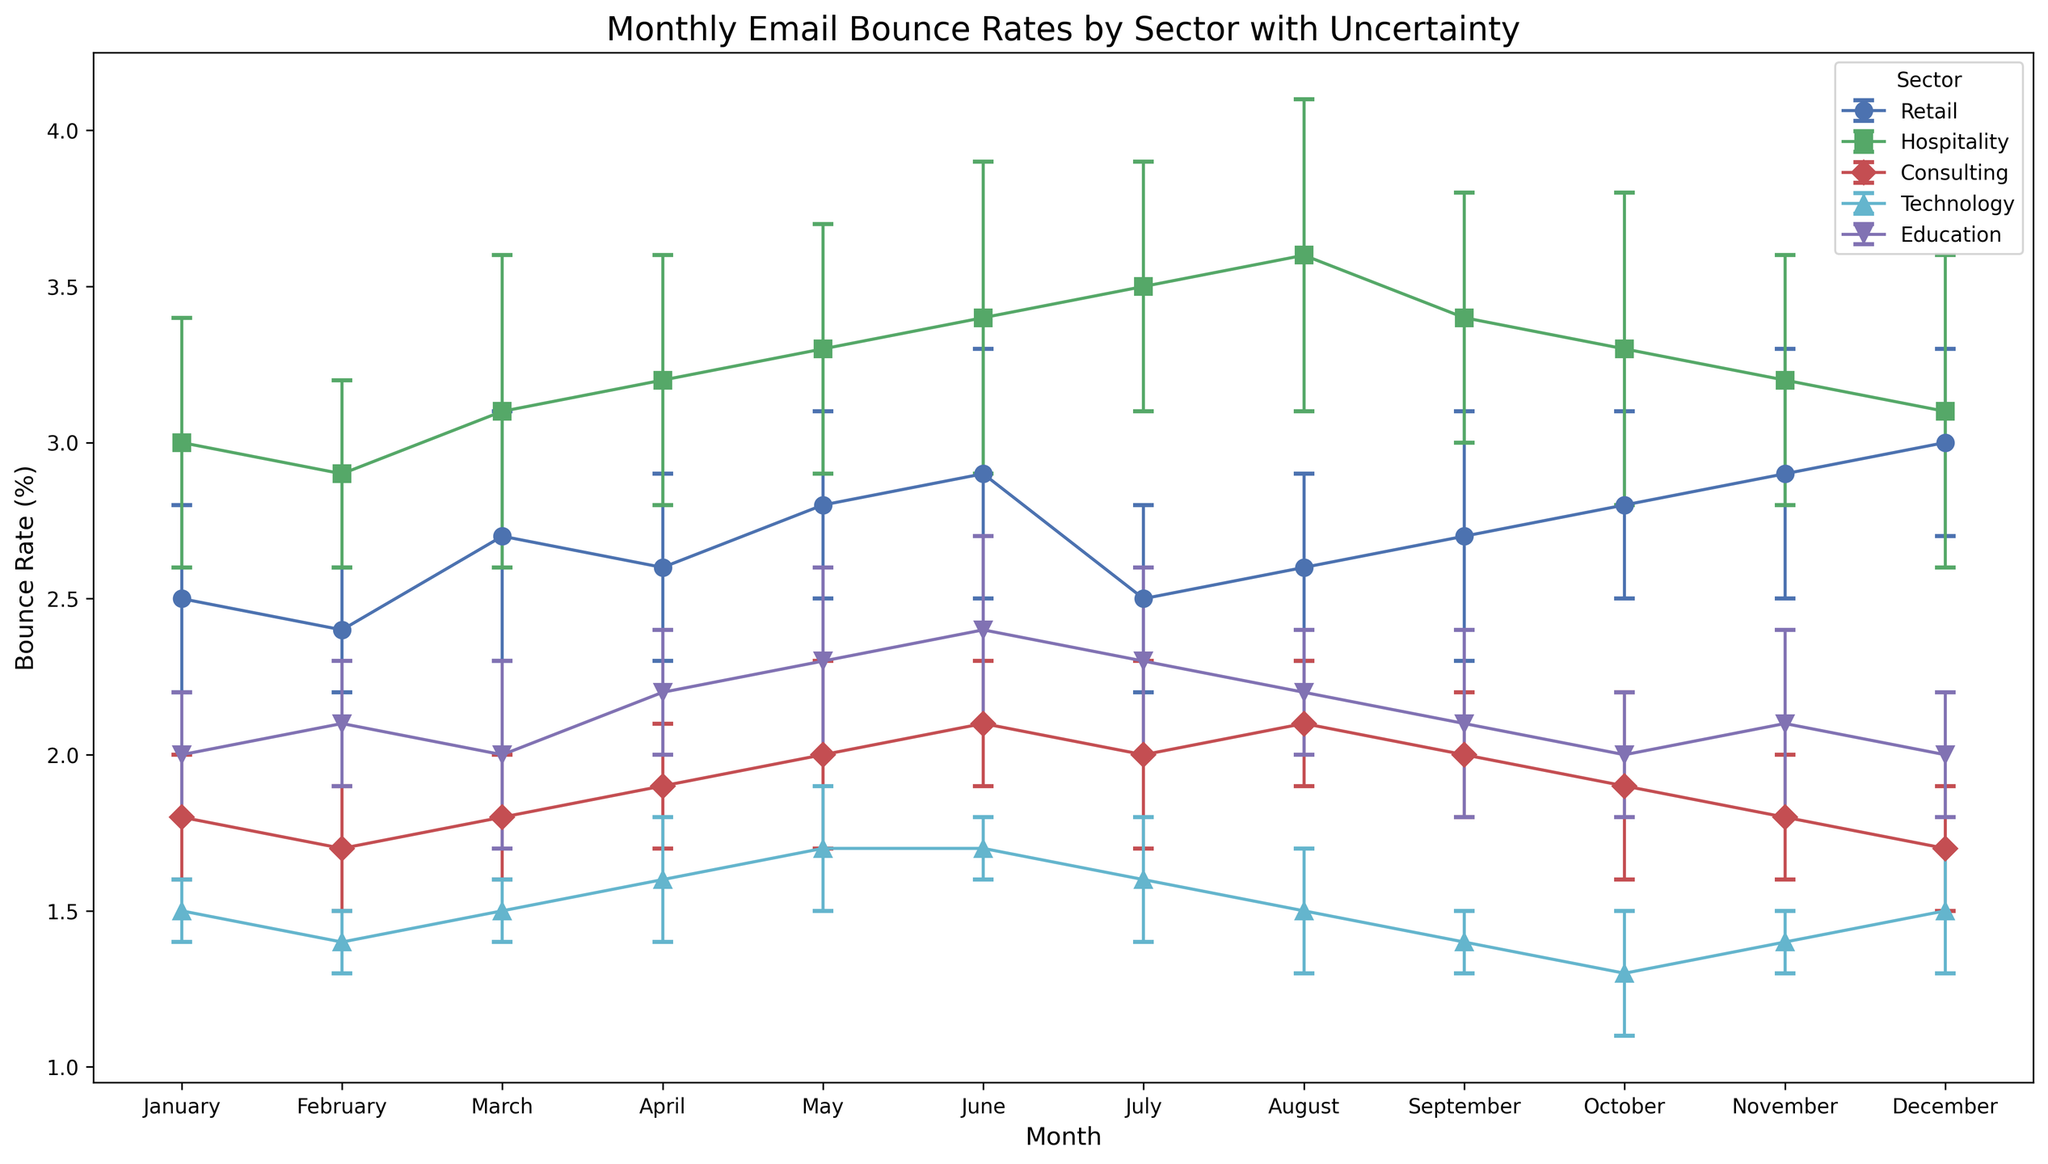What month has the highest bounce rate in the Retail sector? From the plot, we can observe the marker peaks for the Retail sector. By following the highest point, which is marked around December, we find that the bounce rate is the highest in December.
Answer: December Which sector has the highest bounce rate in July? By examining the July markers across all sectors on the figure, we see that the Hospitality sector has the highest marker around 3.5%. This suggests that Hospitality has the highest bounce rate in July.
Answer: Hospitality Compare the bounce rates of Consulting and Technology sectors in May. Which one is higher and by how much? Consulting in May has a bounce rate around 2.0, and Technology is around 1.7. Subtracting the Technology bounce rate from Consulting gives us 2.0 - 1.7 = 0.3. Therefore, Consulting is higher by 0.3.
Answer: Consulting by 0.3 What is the average bounce rate for the Education sector from January to June? Adding the bounce rates from January to June for Education (2.0, 2.1, 2.0, 2.2, 2.3, 2.4) gives us a total of: 2.0 + 2.1 + 2.0 + 2.2 + 2.3 + 2.4 = 13.0. Dividing by 6 (number of months) gives an average of: 13.0 / 6 ≈ 2.17.
Answer: 2.17 Is the bounce rate of Technology consistent throughout the year? Visually scanning the Technology sector line, we notice minor fluctuations around the average but it stays in the range of 1.3 - 1.7 throughout the months. Thus, it's relatively consistent with only small variations.
Answer: Yes Which sector has the least varying bounce rate throughout the year? By looking at the error bars (uncertainty) across all sectors, Consulting has the smallest error ranges, indicating the least variation in bounce rate throughout the year.
Answer: Consulting What is the difference in bounce rate between Retail and Hospitality in November? From the plot, Retail in November is around 2.9 and Hospitality is around 3.2. The difference is: 3.2 - 2.9 = 0.3.
Answer: 0.3 If the bounce rates in the Retail sector for April, May, and June were averaged, what would it be? Adding bounce rates for April (2.6), May (2.8), and June (2.9): 2.6 + 2.8 + 2.9 = 8.3. Dividing by 3 gives us: 8.3 / 3 ≈ 2.77.
Answer: 2.77 Which sector has the largest bounce rate in October and what is the rate? Checking October markers, Hospitality's marker is the highest around 3.3. Thus, Hospitality has the largest bounce rate in October, approximately 3.3.
Answer: Hospitality, 3.3 